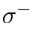<formula> <loc_0><loc_0><loc_500><loc_500>\sigma ^ { - }</formula> 